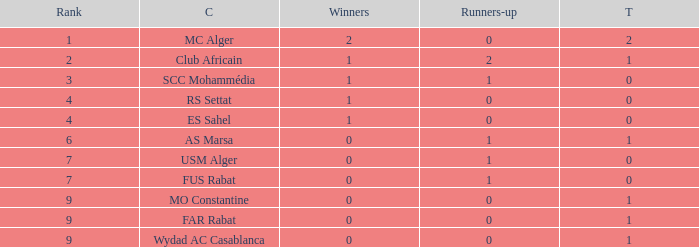Which Third has Runners-up of 0, and Winners of 0, and a Club of far rabat? 1.0. 